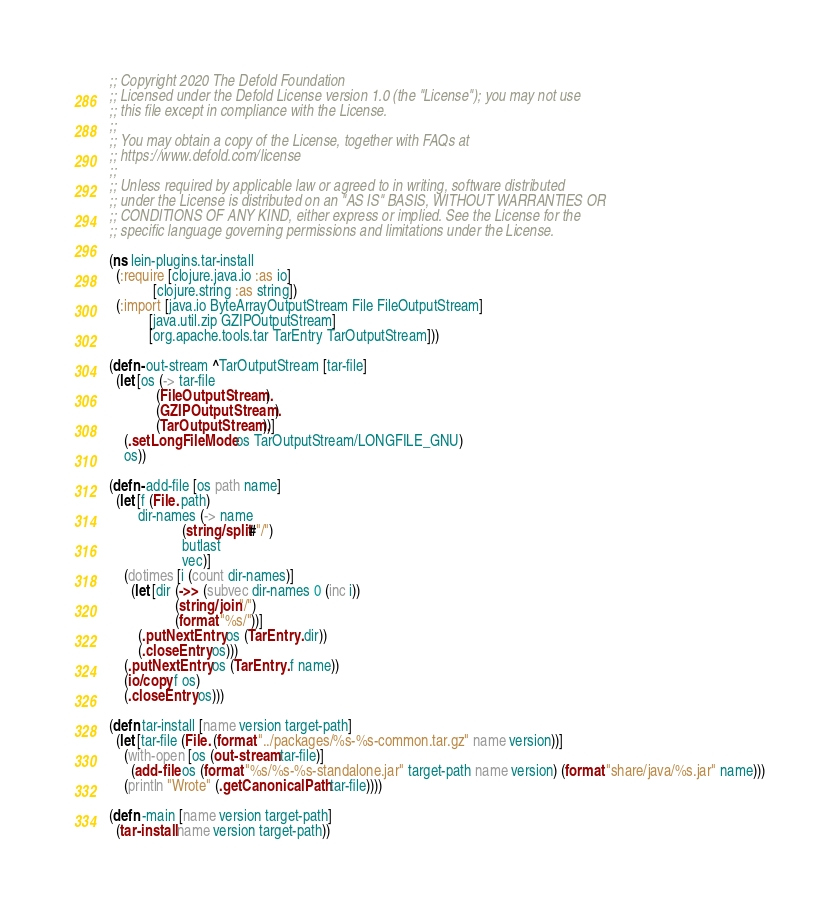Convert code to text. <code><loc_0><loc_0><loc_500><loc_500><_Clojure_>;; Copyright 2020 The Defold Foundation
;; Licensed under the Defold License version 1.0 (the "License"); you may not use
;; this file except in compliance with the License.
;; 
;; You may obtain a copy of the License, together with FAQs at
;; https://www.defold.com/license
;; 
;; Unless required by applicable law or agreed to in writing, software distributed
;; under the License is distributed on an "AS IS" BASIS, WITHOUT WARRANTIES OR
;; CONDITIONS OF ANY KIND, either express or implied. See the License for the
;; specific language governing permissions and limitations under the License.

(ns lein-plugins.tar-install
  (:require [clojure.java.io :as io]
            [clojure.string :as string])
  (:import [java.io ByteArrayOutputStream File FileOutputStream]
           [java.util.zip GZIPOutputStream]
           [org.apache.tools.tar TarEntry TarOutputStream]))

(defn- out-stream ^TarOutputStream [tar-file]
  (let [os (-> tar-file
             (FileOutputStream.)
             (GZIPOutputStream.)
             (TarOutputStream.))]
    (.setLongFileMode os TarOutputStream/LONGFILE_GNU)
    os))

(defn- add-file [os path name]
  (let [f (File. path)
        dir-names (-> name
                    (string/split #"/")
                    butlast
                    vec)]
    (dotimes [i (count dir-names)]
      (let [dir (->> (subvec dir-names 0 (inc i))
                  (string/join "/")
                  (format "%s/"))]
        (.putNextEntry os (TarEntry. dir))
        (.closeEntry os)))
    (.putNextEntry os (TarEntry. f name))
    (io/copy f os)
    (.closeEntry os)))

(defn tar-install [name version target-path]
  (let [tar-file (File. (format "../packages/%s-%s-common.tar.gz" name version))]
    (with-open [os (out-stream tar-file)]
      (add-file os (format "%s/%s-%s-standalone.jar" target-path name version) (format "share/java/%s.jar" name)))
    (println "Wrote" (.getCanonicalPath tar-file))))

(defn -main [name version target-path]
  (tar-install name version target-path))</code> 